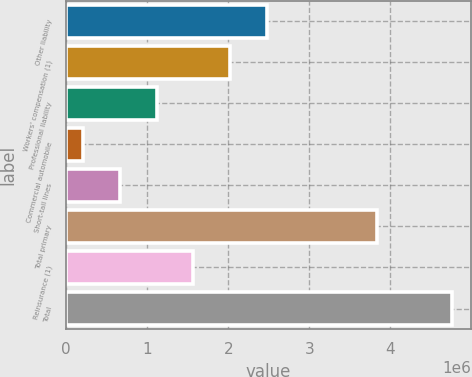Convert chart to OTSL. <chart><loc_0><loc_0><loc_500><loc_500><bar_chart><fcel>Other liability<fcel>Workers' compensation (1)<fcel>Professional liability<fcel>Commercial automobile<fcel>Short-tail lines<fcel>Total primary<fcel>Reinsurance (1)<fcel>Total<nl><fcel>2.48167e+06<fcel>2.02642e+06<fcel>1.11591e+06<fcel>205404<fcel>660657<fcel>3.83936e+06<fcel>1.57116e+06<fcel>4.75793e+06<nl></chart> 